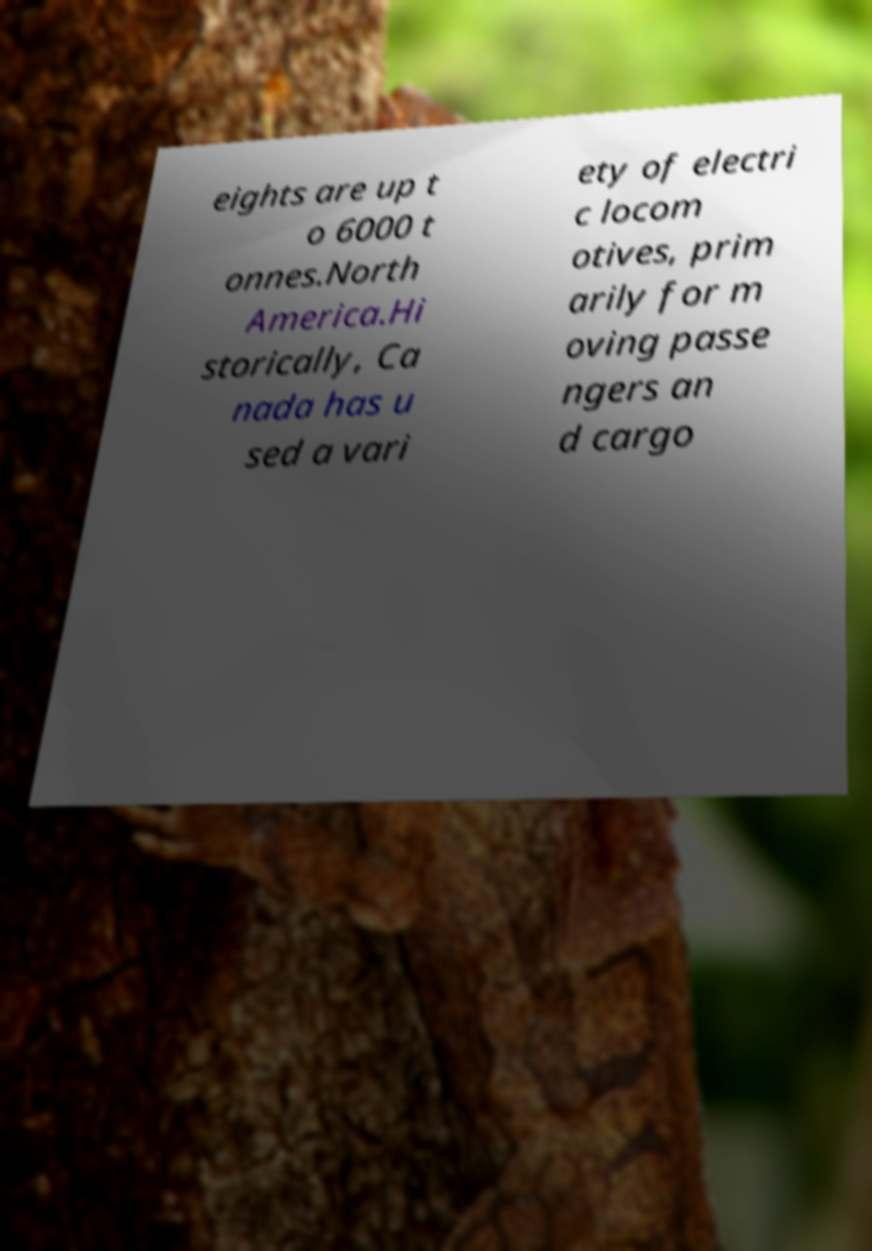What messages or text are displayed in this image? I need them in a readable, typed format. eights are up t o 6000 t onnes.North America.Hi storically, Ca nada has u sed a vari ety of electri c locom otives, prim arily for m oving passe ngers an d cargo 